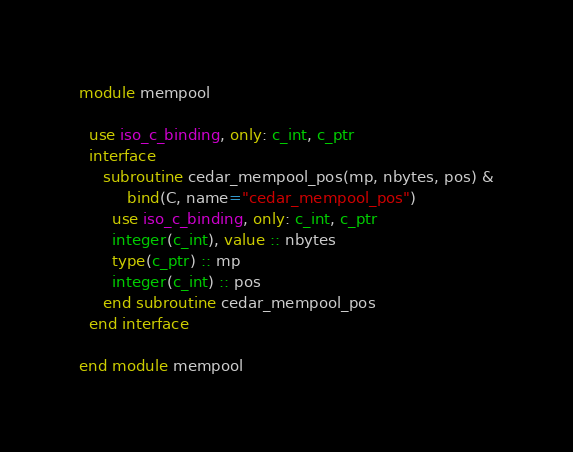Convert code to text. <code><loc_0><loc_0><loc_500><loc_500><_FORTRAN_>module mempool

  use iso_c_binding, only: c_int, c_ptr
  interface
     subroutine cedar_mempool_pos(mp, nbytes, pos) &
          bind(C, name="cedar_mempool_pos")
       use iso_c_binding, only: c_int, c_ptr
       integer(c_int), value :: nbytes
       type(c_ptr) :: mp
       integer(c_int) :: pos
     end subroutine cedar_mempool_pos
  end interface

end module mempool
</code> 